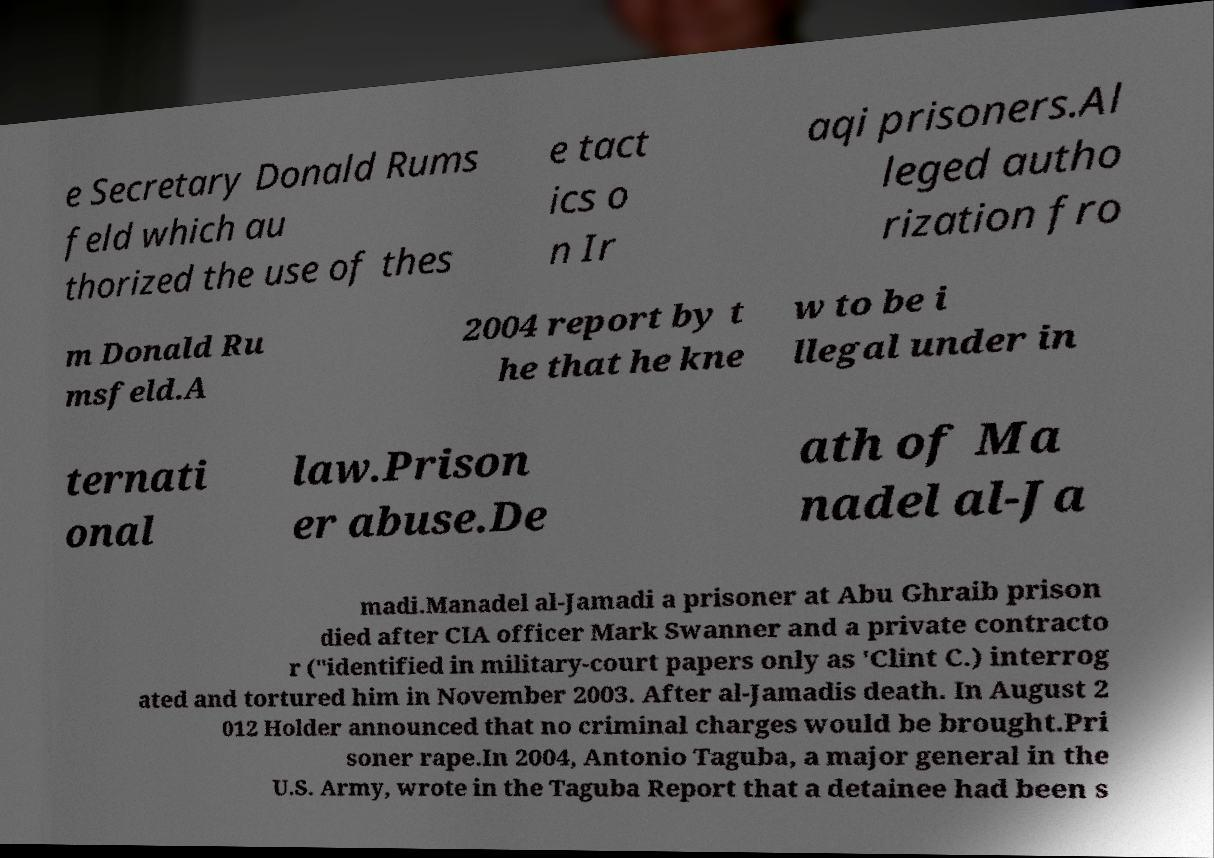Could you assist in decoding the text presented in this image and type it out clearly? e Secretary Donald Rums feld which au thorized the use of thes e tact ics o n Ir aqi prisoners.Al leged autho rization fro m Donald Ru msfeld.A 2004 report by t he that he kne w to be i llegal under in ternati onal law.Prison er abuse.De ath of Ma nadel al-Ja madi.Manadel al-Jamadi a prisoner at Abu Ghraib prison died after CIA officer Mark Swanner and a private contracto r ("identified in military-court papers only as 'Clint C.) interrog ated and tortured him in November 2003. After al-Jamadis death. In August 2 012 Holder announced that no criminal charges would be brought.Pri soner rape.In 2004, Antonio Taguba, a major general in the U.S. Army, wrote in the Taguba Report that a detainee had been s 